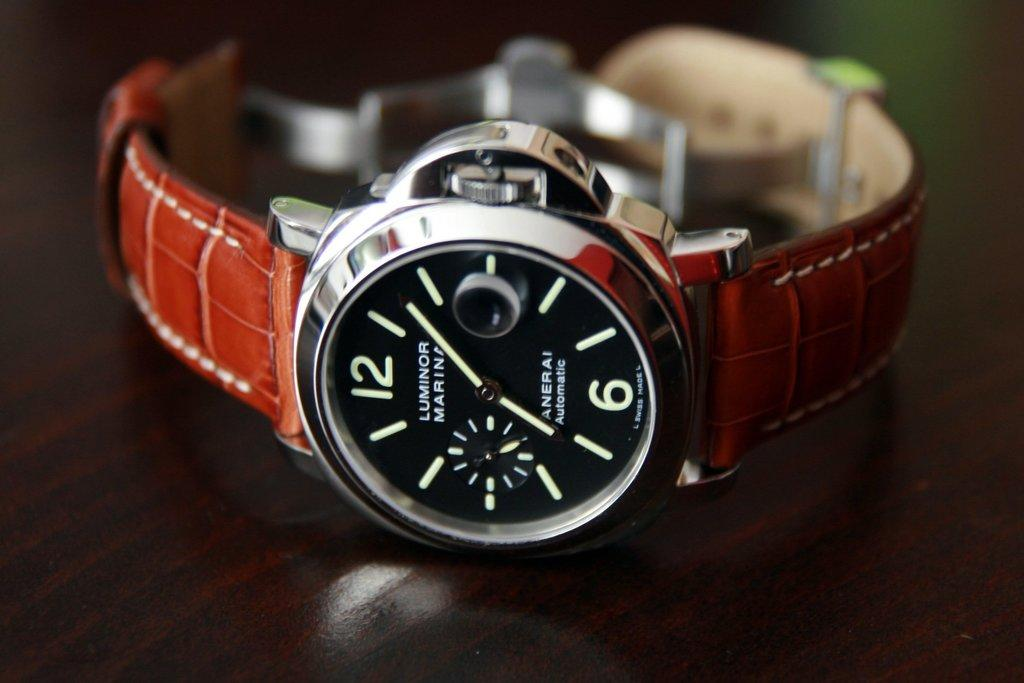Provide a one-sentence caption for the provided image. A Luminor watch that's been displayed on a table. 